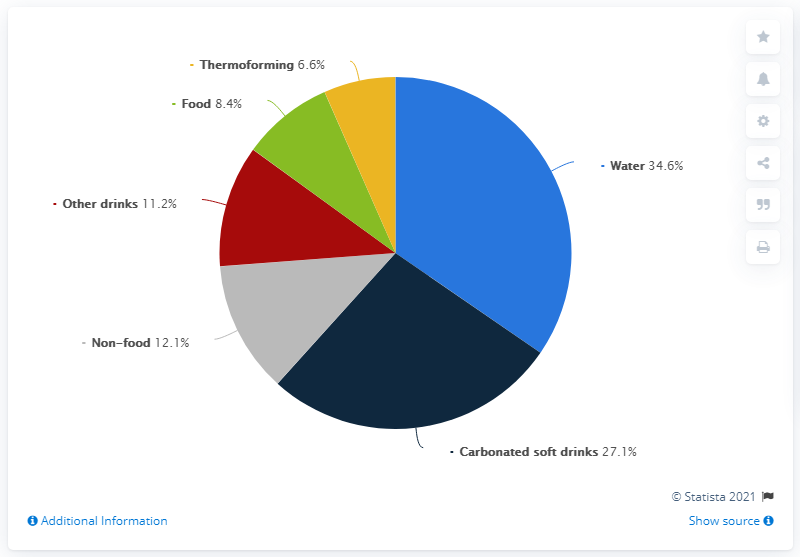Draw attention to some important aspects in this diagram. The percentage of PET in carbonated drinks is 27.1%. Six end-use sectors are included in the graph. According to data from 2019, bottled water accounted for approximately 34.6% of the global consumption of PET packaging. 